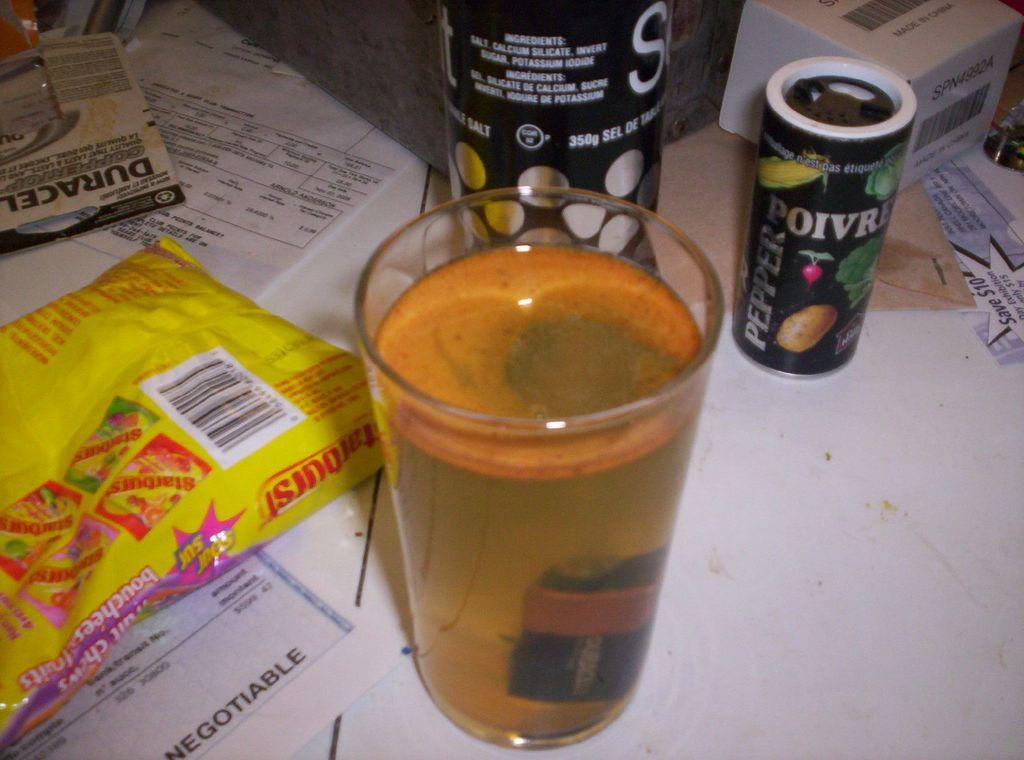<image>
Offer a succinct explanation of the picture presented. A glass of liquid on a desk next to a pack of Starburst 